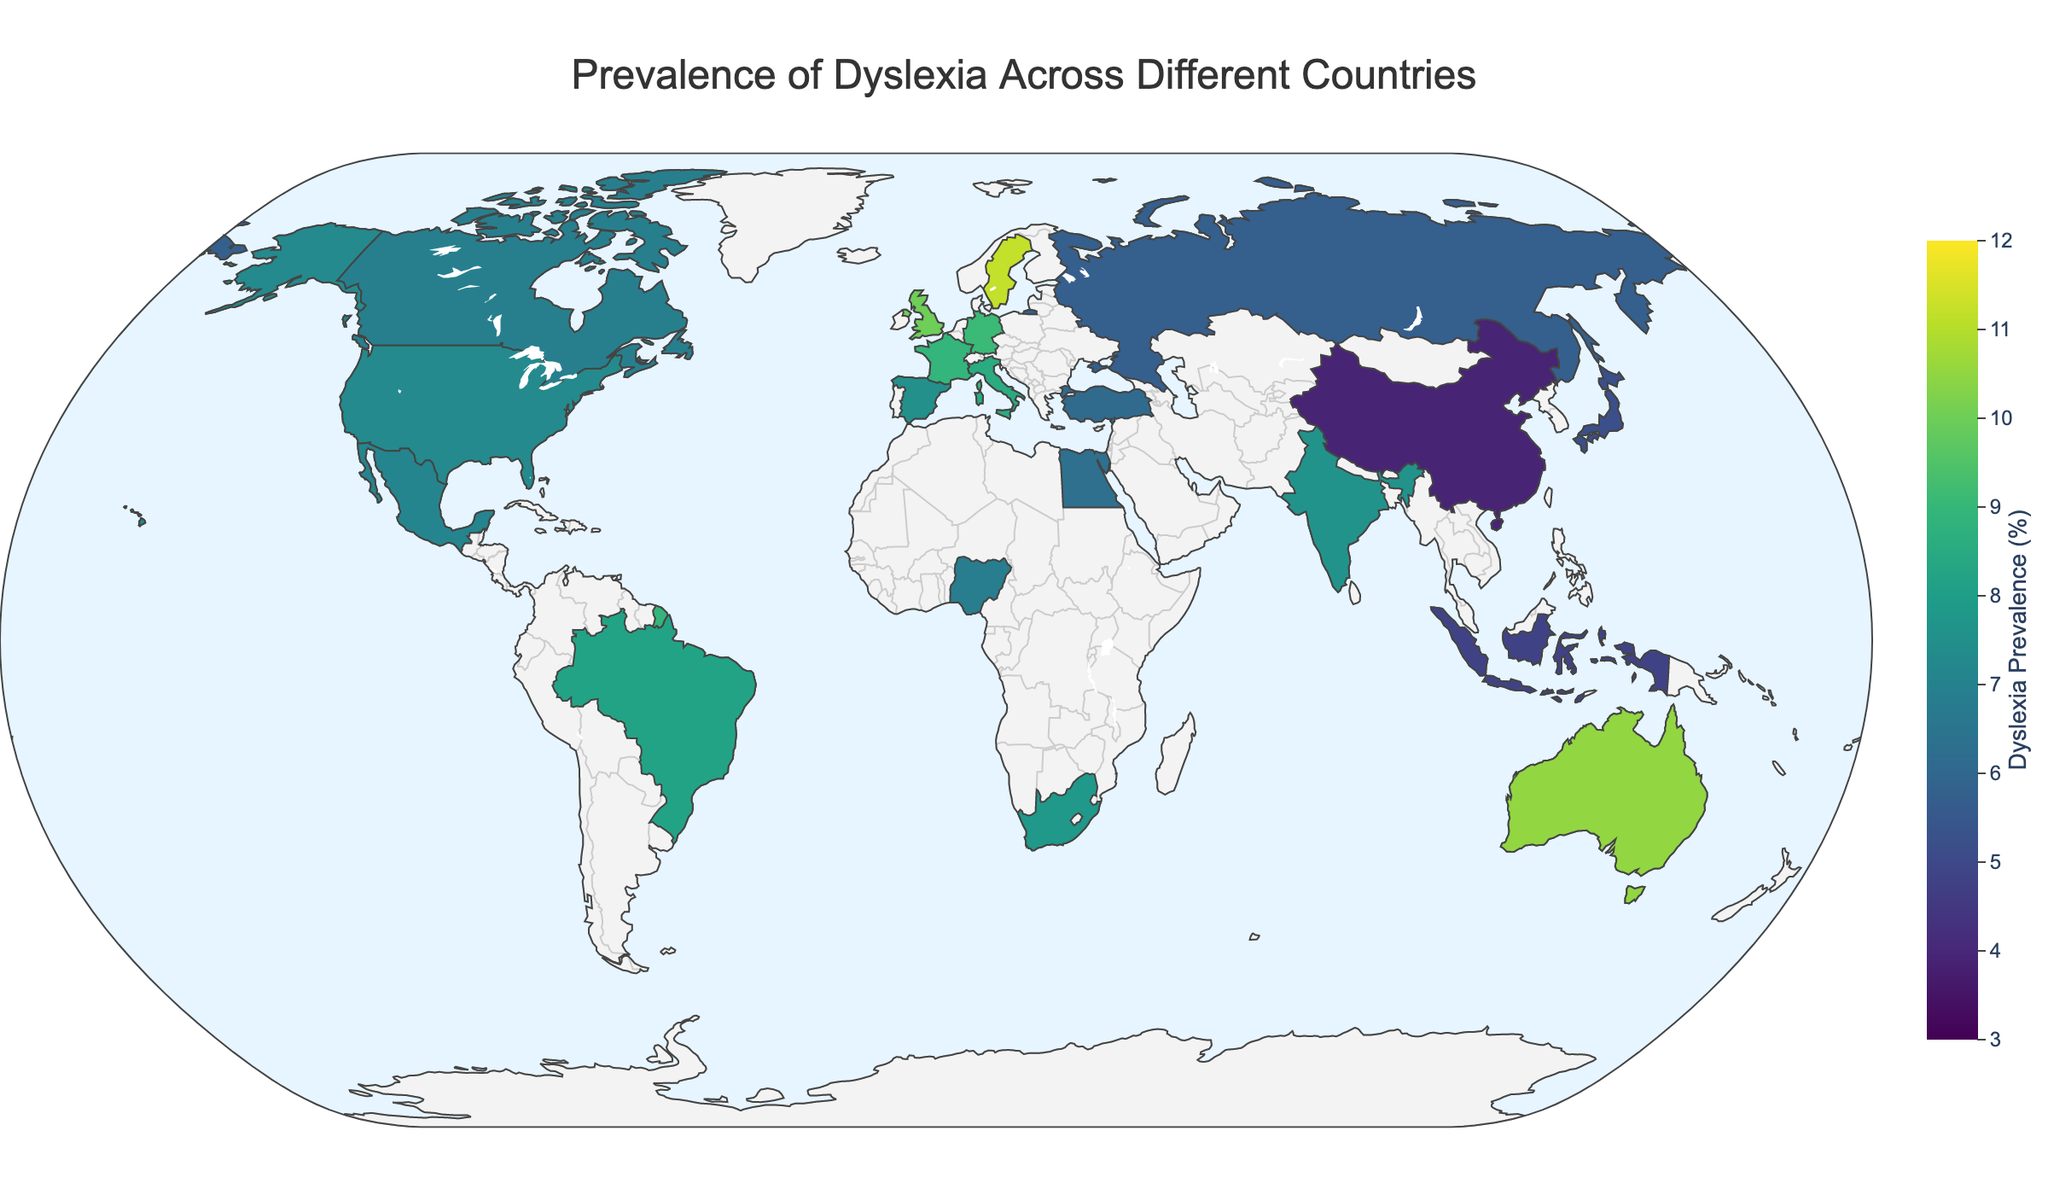Which country has the highest prevalence of dyslexia? To find the country with the highest prevalence, look for the region with the darkest shade corresponding to the highest color value in the range.
Answer: Sweden Which region has the widest range of dyslexia prevalence among its countries? To determine this, identify a region with multiple countries that display a significant variance in color intensity (light to dark). Europe has countries like Sweden with 11.2% and Russia with 5.7%, indicating a wide range.
Answer: Europe What is the average dyslexia prevalence in Asia? Asia includes China (3.9), Japan (5.2), India (7.6), and Indonesia (4.8). Sum these values and divide by the number of countries: (3.9 + 5.2 + 7.6 + 4.8) / 4.
Answer: 5.375 Which countries have dyslexia prevalence rates above 10%? Identify countries on the map colored with the darkest shades and check their prevalence values. These include the United Kingdom, Australia, and Sweden.
Answer: United Kingdom, Australia, Sweden What is the difference in dyslexia prevalence between the United States and Brazil? Locate the prevalence rates for the United States (7.3) and Brazil (8.2), then subtract the values: 8.2 - 7.3.
Answer: 0.9 Which region has the least variation in dyslexia prevalence among its countries? Assess the clusters of colors in different regions to find the one with similar shading. North America has close values: United States (7.3), Canada (6.9), Mexico (7.1).
Answer: North America How does the dyslexia prevalence in Germany compare with Italy? Look at Germany (9.1) and Italy (8.5) and compare the values to see which is higher.
Answer: Germany has a higher prevalence than Italy Name three countries from any continent with the lowest dyslexia prevalence. Look for the lightest shades indicating the lowest values. In Asia, China (3.9), Indonesia (4.8), and Japan (5.2) have low prevalences.
Answer: China, Indonesia, Japan How does the dyslexia prevalence in Germany compare with India? Locate Germany's prevalence (9.1) and India's (7.6), and then compare them directly.
Answer: Germany has a higher prevalence than India What is the median dyslexia prevalence in Europe? For Europe, list the prevalences: United Kingdom (10.0), Germany (9.1), Italy (8.5), Russia (5.7), Sweden (11.2), France (8.9), Spain (7.5), Turkey (6.1). Arrange them in order, and the median is the middle value(s): [5.7, 6.1, 7.5, 8.5, 8.9, 9.1, 10.0, 11.2].
Answer: 8.7 